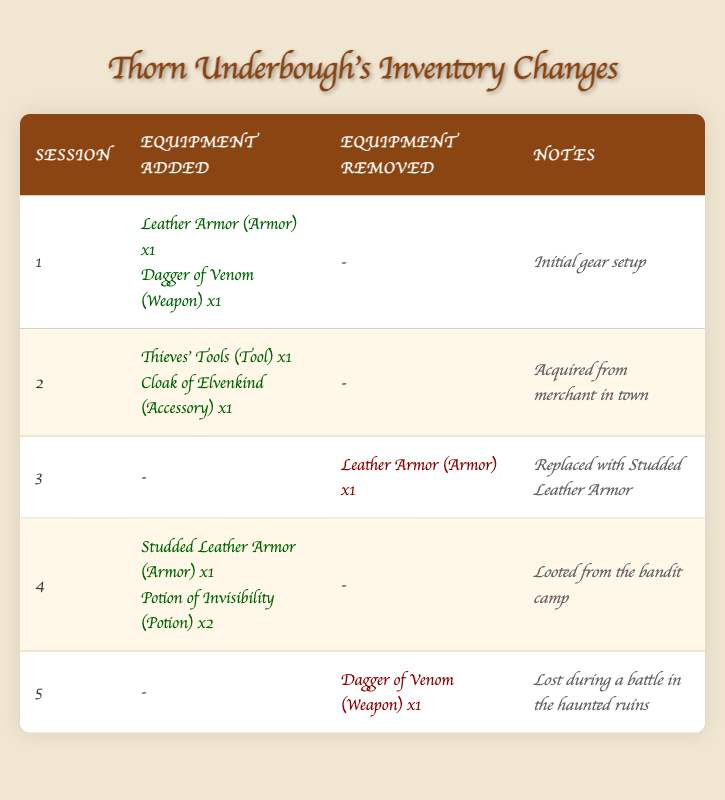What items did Thorn Underbough acquire in session 2? In session 2, Thorn Underbough added "Thieves' Tools" and "Cloak of Elvenkind" to his inventory. These items are listed under the "Equipment Added" column for session 2.
Answer: Thieves' Tools, Cloak of Elvenkind Did Thorn Underbough lose the Dagger of Venom? Yes, in session 5, the table indicates that Thorn removed the "Dagger of Venom" during a battle, which implies that he lost it.
Answer: Yes How many armor pieces does Thorn Underbough have after session 4? After session 4, Thorn has "Studded Leather Armor" as the only armor piece added in that session and no others were removed since the last session that had armor removed was in session 3. Therefore, he has one armor piece.
Answer: 1 What was the last equipment Thorn Underbough removed before session 5? Before session 5, Thorn removed "Leather Armor" in session 3; this is noted in the "Equipment Removed" column for that session. Session 5 has the removal of "Dagger of Venom," but that's after the "Leather Armor."
Answer: Leather Armor What is the total quantity of potions Thorn Underbough acquired in session 4? Thorn added "Potion of Invisibility" with a quantity of 2 in session 4; thus, the total quantity of potions acquired in that session is 2.
Answer: 2 What type of equipment did Thorn Underbough add in his very first session? In session 1, Thorn added "Leather Armor" and "Dagger of Venom." These items help to establish his initial gear, comprising one armor and one weapon type.
Answer: Armor, Weapon Did Thorn Underbough replace any equipment in session 4? No, Thorn did not replace any equipment in session 4; he only added new items: "Studded Leather Armor" and "Potion of Invisibility." Therefore, there was no removal or replacement of existing items during that session.
Answer: No How many total items did Thorn add to his inventory over the five sessions? To find the total added items, we sum the quantities from each session: 2 (session 1) + 2 (session 2) + 1 (session 4) = 5 items added in total. Session 3 and 5 had no additions, just removals.
Answer: 5 What were the reasons outlined in the notes for Thorn Underbough's equipment changes? The notes specify: session 1 is "Initial gear setup," session 2 indicates "Acquired from merchant in town," session 3 mentions "Replaced with Studded Leather Armor," session 4 states "Looted from the bandit camp," and session 5 notes "Lost during a battle in the haunted ruins."
Answer: Various reasons 